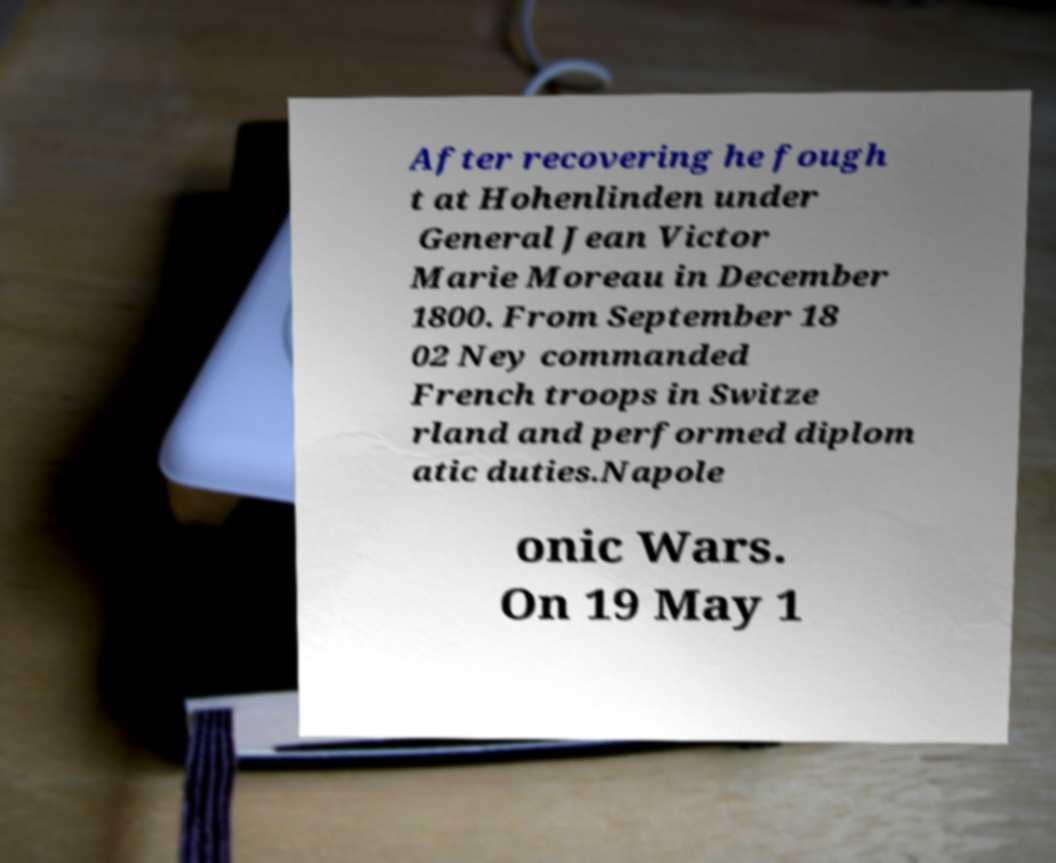For documentation purposes, I need the text within this image transcribed. Could you provide that? After recovering he fough t at Hohenlinden under General Jean Victor Marie Moreau in December 1800. From September 18 02 Ney commanded French troops in Switze rland and performed diplom atic duties.Napole onic Wars. On 19 May 1 